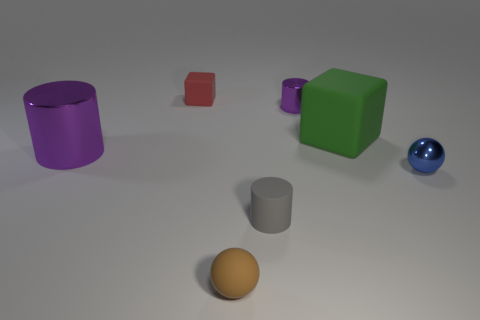What is the shape of the small brown matte object? sphere 